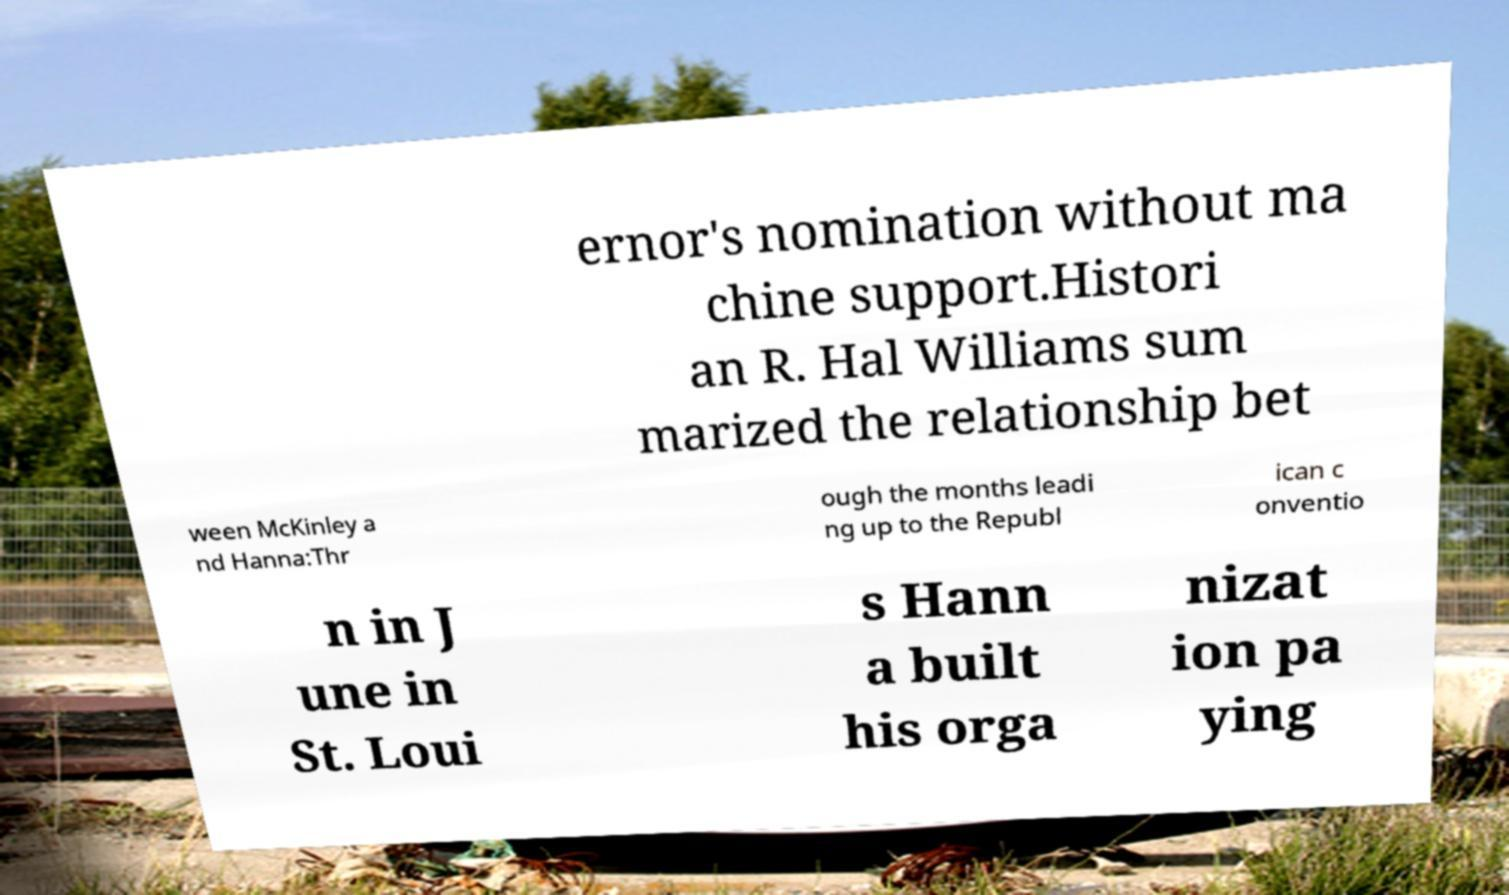Can you accurately transcribe the text from the provided image for me? ernor's nomination without ma chine support.Histori an R. Hal Williams sum marized the relationship bet ween McKinley a nd Hanna:Thr ough the months leadi ng up to the Republ ican c onventio n in J une in St. Loui s Hann a built his orga nizat ion pa ying 